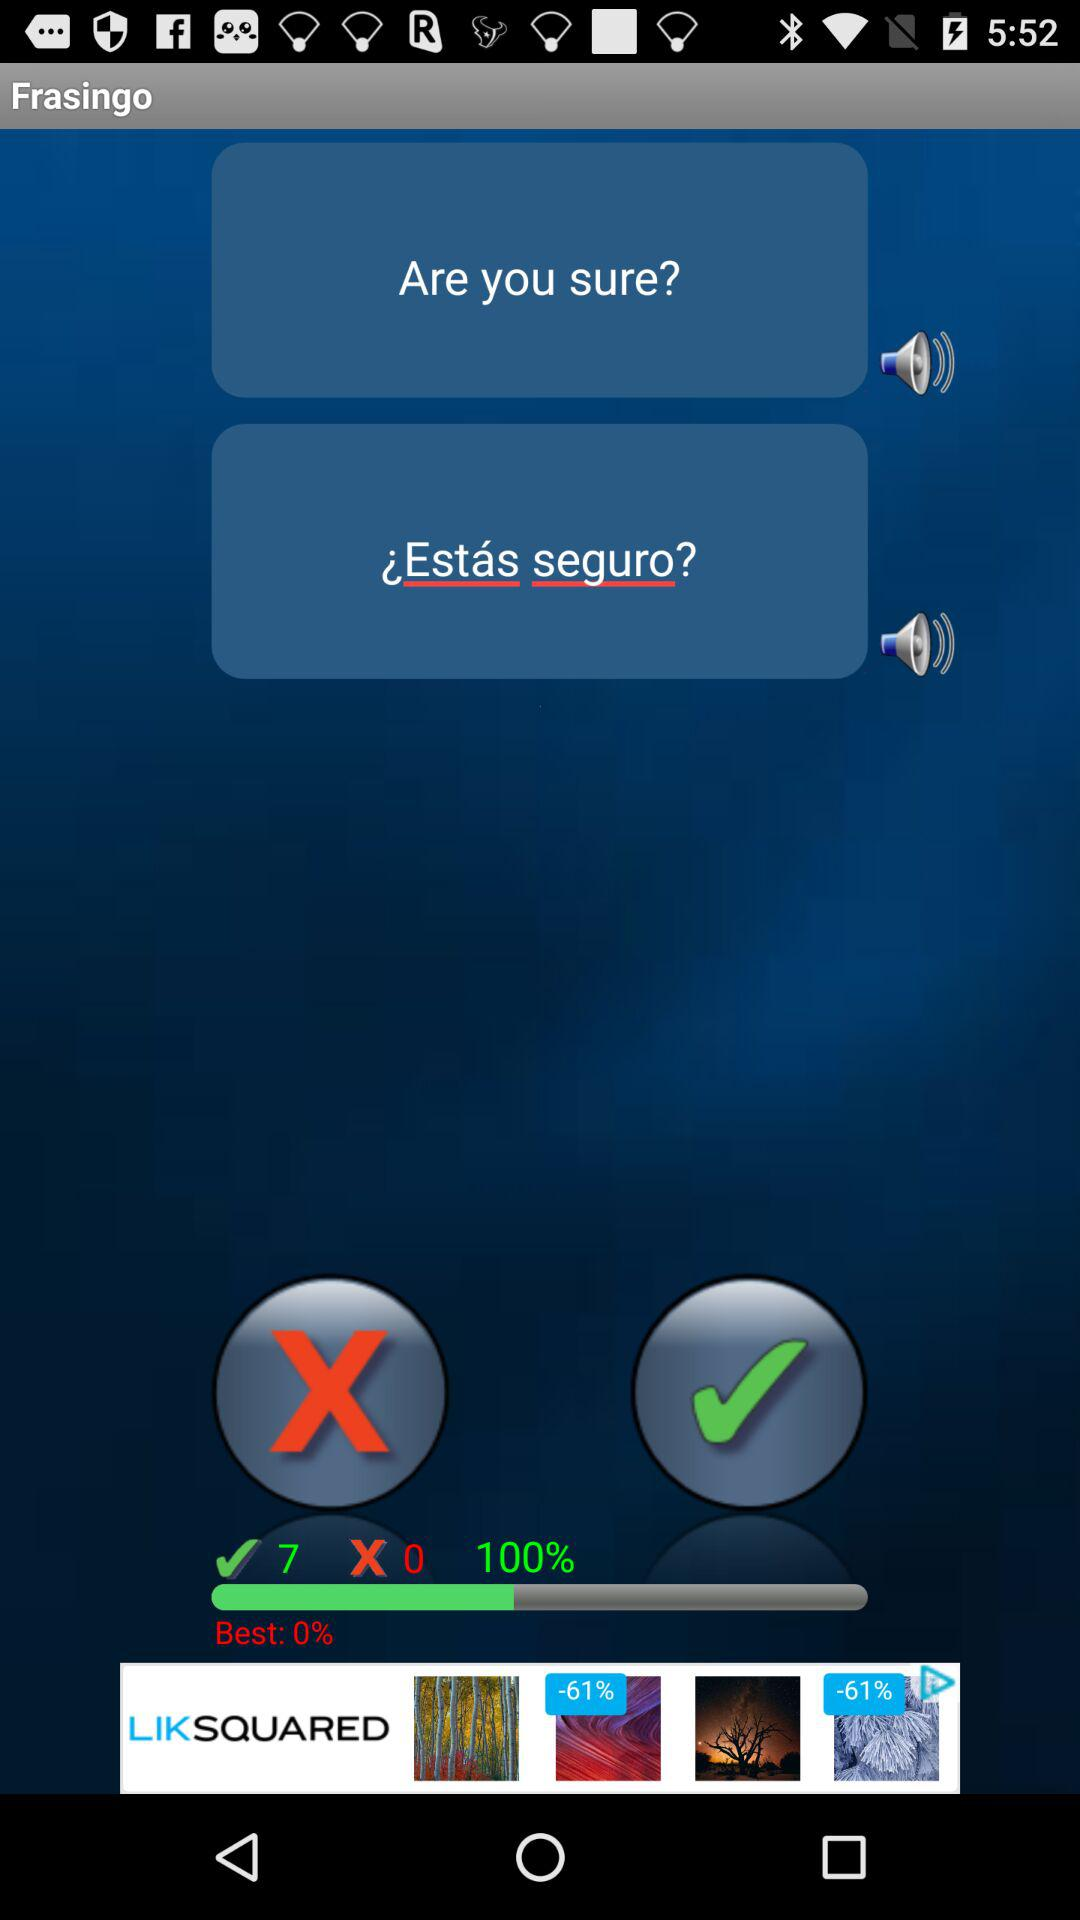What's the percentage? The percentage is 100. 